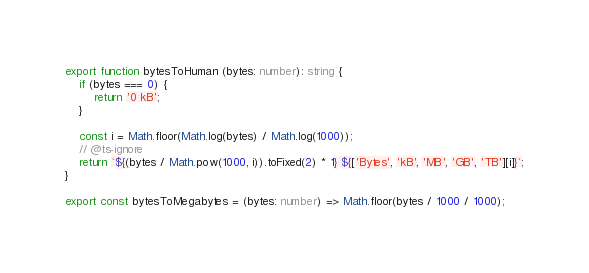Convert code to text. <code><loc_0><loc_0><loc_500><loc_500><_TypeScript_>export function bytesToHuman (bytes: number): string {
    if (bytes === 0) {
        return '0 kB';
    }

    const i = Math.floor(Math.log(bytes) / Math.log(1000));
    // @ts-ignore
    return `${(bytes / Math.pow(1000, i)).toFixed(2) * 1} ${['Bytes', 'kB', 'MB', 'GB', 'TB'][i]}`;
}

export const bytesToMegabytes = (bytes: number) => Math.floor(bytes / 1000 / 1000);
</code> 